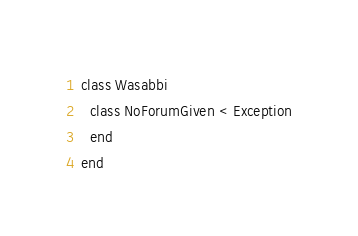Convert code to text. <code><loc_0><loc_0><loc_500><loc_500><_Ruby_>class Wasabbi
  class NoForumGiven < Exception
  end
end
</code> 